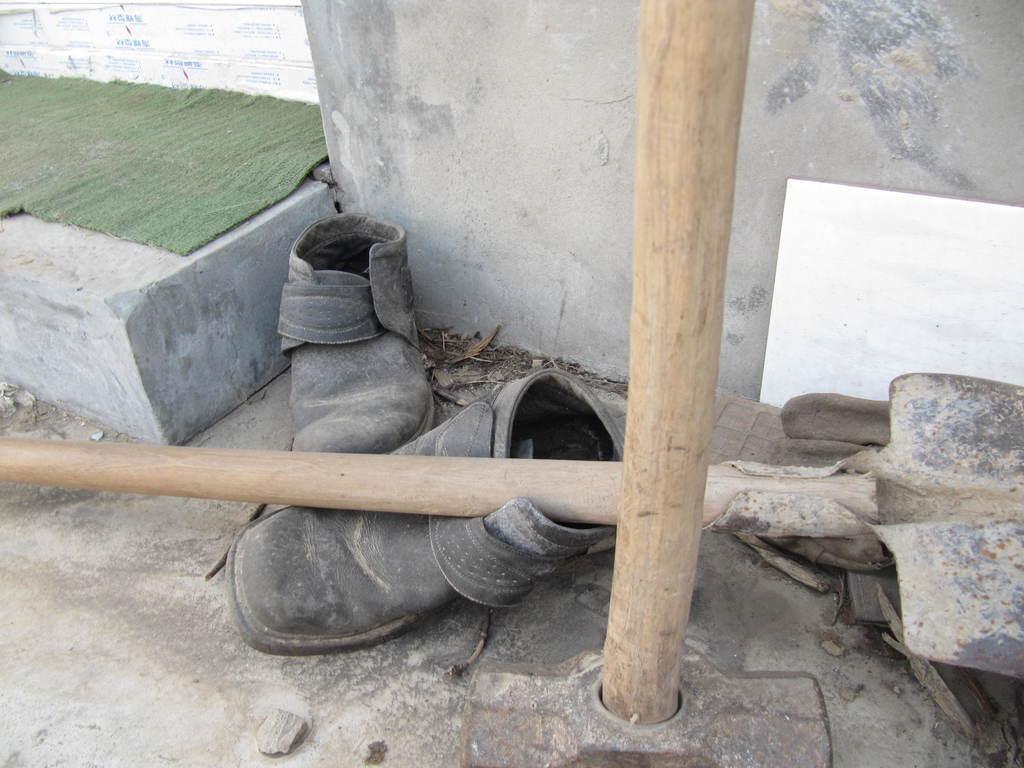Could you give a brief overview of what you see in this image? In this picture there are shoes, beside that there are bamboos. On the left there is a green carpet on the concrete brick. On the right there is a poster near to the wall. 